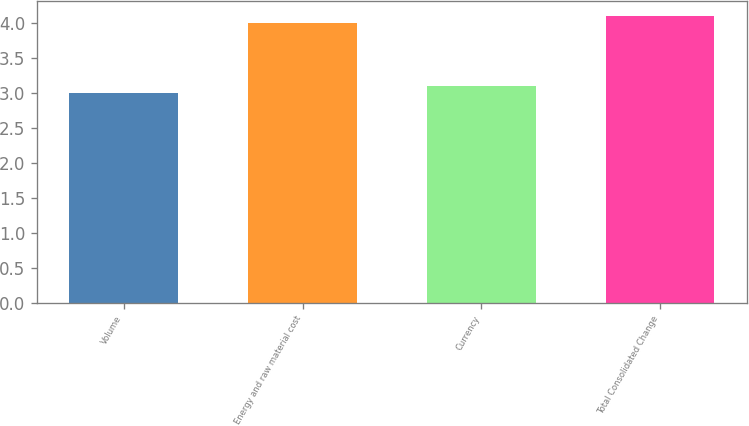Convert chart to OTSL. <chart><loc_0><loc_0><loc_500><loc_500><bar_chart><fcel>Volume<fcel>Energy and raw material cost<fcel>Currency<fcel>Total Consolidated Change<nl><fcel>3<fcel>4<fcel>3.1<fcel>4.1<nl></chart> 